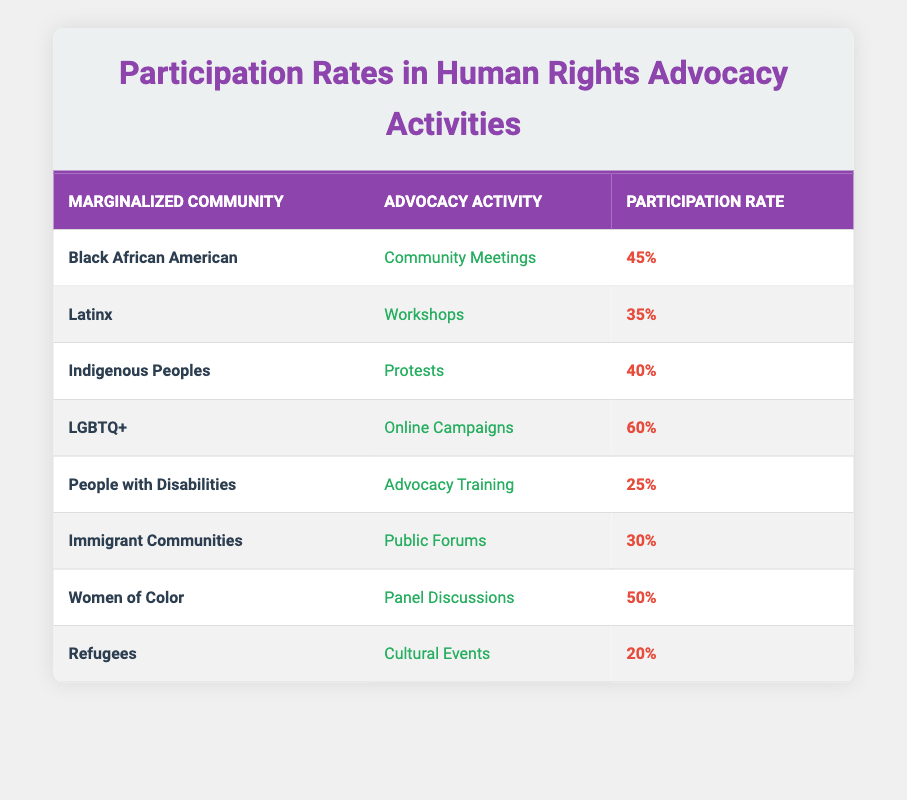What is the participation rate of LGBTQ+ in Online Campaigns? According to the table, the participation rate for LGBTQ+ in Online Campaigns is listed directly in the participation rate column.
Answer: 60 Which advocacy activity had the lowest participation rate? By reviewing the table, we find that the participation rates of each activity are: Community Meetings - 45, Workshops - 35, Protests - 40, Online Campaigns - 60, Advocacy Training - 25, Public Forums - 30, Panel Discussions - 50, Cultural Events - 20. The lowest rate is for Cultural Events.
Answer: Cultural Events What is the average participation rate for all activities listed? To find the average, sum all participation rates: 45 + 35 + 40 + 60 + 25 + 30 + 50 + 20 = 305. There are 8 activities, so the average is 305 / 8 = 38.125.
Answer: 38.125 Is the participation rate of Women of Color higher than that of Immigrant Communities in their respective activities? The participation rate for Women of Color in Panel Discussions is 50, while for Immigrant Communities in Public Forums it is 30. Since 50 is greater than 30, the statement is true.
Answer: Yes What is the difference in participation rates between Indigenous Peoples’ Protests and Latinx Workshops? The participation rate for Indigenous Peoples in Protests is 40 and for Latinx in Workshops it is 35. To find the difference, subtract 35 from 40, which gives us 5.
Answer: 5 